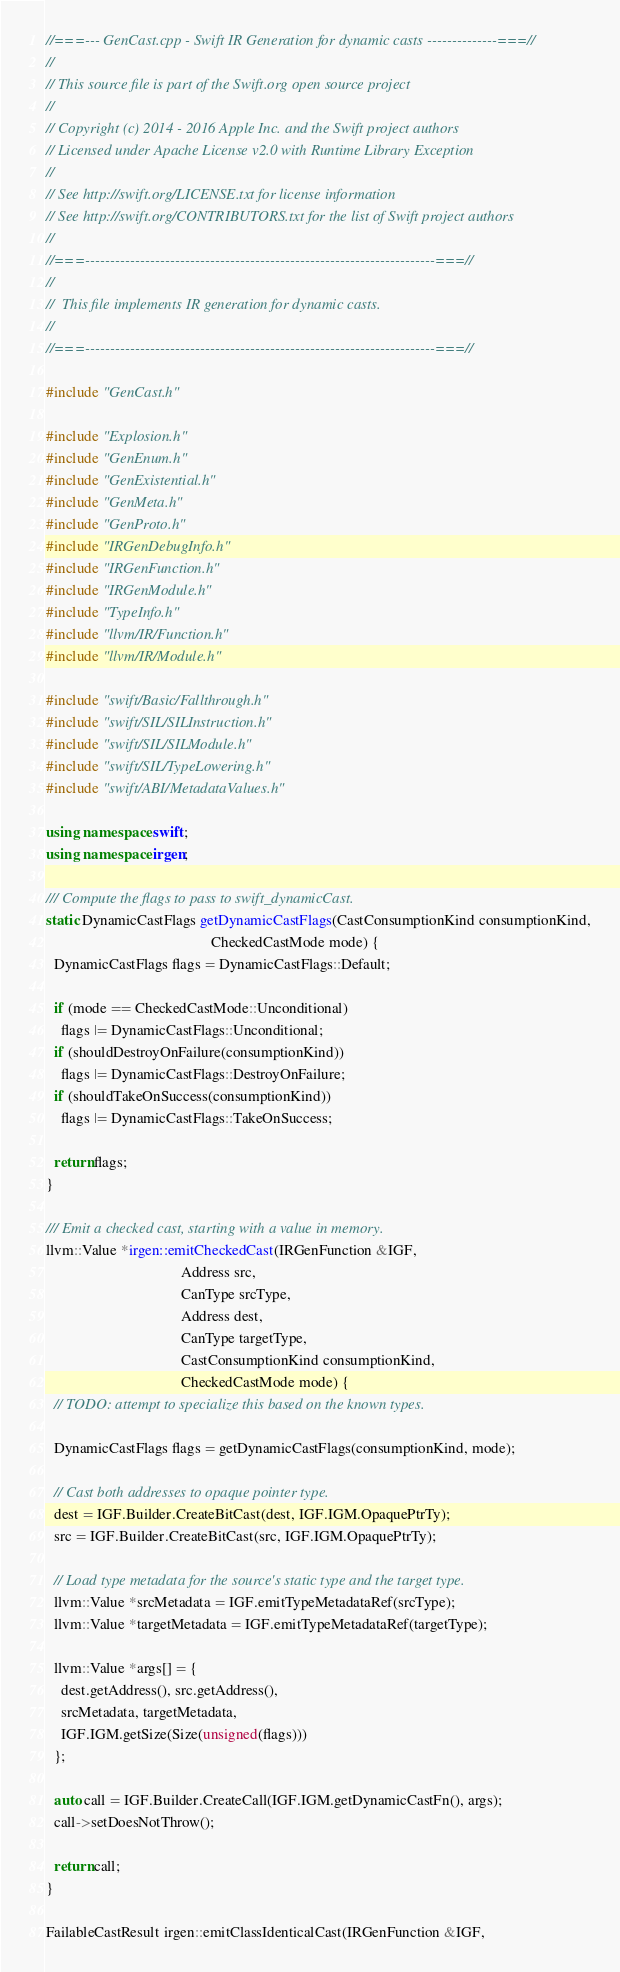Convert code to text. <code><loc_0><loc_0><loc_500><loc_500><_C++_>//===--- GenCast.cpp - Swift IR Generation for dynamic casts --------------===//
//
// This source file is part of the Swift.org open source project
//
// Copyright (c) 2014 - 2016 Apple Inc. and the Swift project authors
// Licensed under Apache License v2.0 with Runtime Library Exception
//
// See http://swift.org/LICENSE.txt for license information
// See http://swift.org/CONTRIBUTORS.txt for the list of Swift project authors
//
//===----------------------------------------------------------------------===//
//
//  This file implements IR generation for dynamic casts.
//
//===----------------------------------------------------------------------===//

#include "GenCast.h"

#include "Explosion.h"
#include "GenEnum.h"
#include "GenExistential.h"
#include "GenMeta.h"
#include "GenProto.h"
#include "IRGenDebugInfo.h"
#include "IRGenFunction.h"
#include "IRGenModule.h"
#include "TypeInfo.h"
#include "llvm/IR/Function.h"
#include "llvm/IR/Module.h"

#include "swift/Basic/Fallthrough.h"
#include "swift/SIL/SILInstruction.h"
#include "swift/SIL/SILModule.h"
#include "swift/SIL/TypeLowering.h"
#include "swift/ABI/MetadataValues.h"

using namespace swift;
using namespace irgen;

/// Compute the flags to pass to swift_dynamicCast.
static DynamicCastFlags getDynamicCastFlags(CastConsumptionKind consumptionKind,
                                            CheckedCastMode mode) {
  DynamicCastFlags flags = DynamicCastFlags::Default;

  if (mode == CheckedCastMode::Unconditional)
    flags |= DynamicCastFlags::Unconditional;
  if (shouldDestroyOnFailure(consumptionKind))
    flags |= DynamicCastFlags::DestroyOnFailure;
  if (shouldTakeOnSuccess(consumptionKind))
    flags |= DynamicCastFlags::TakeOnSuccess;

  return flags;
}

/// Emit a checked cast, starting with a value in memory.
llvm::Value *irgen::emitCheckedCast(IRGenFunction &IGF,
                                    Address src,
                                    CanType srcType,
                                    Address dest,
                                    CanType targetType,
                                    CastConsumptionKind consumptionKind,
                                    CheckedCastMode mode) {
  // TODO: attempt to specialize this based on the known types.

  DynamicCastFlags flags = getDynamicCastFlags(consumptionKind, mode);

  // Cast both addresses to opaque pointer type.
  dest = IGF.Builder.CreateBitCast(dest, IGF.IGM.OpaquePtrTy);
  src = IGF.Builder.CreateBitCast(src, IGF.IGM.OpaquePtrTy);

  // Load type metadata for the source's static type and the target type.
  llvm::Value *srcMetadata = IGF.emitTypeMetadataRef(srcType);
  llvm::Value *targetMetadata = IGF.emitTypeMetadataRef(targetType);

  llvm::Value *args[] = {
    dest.getAddress(), src.getAddress(),
    srcMetadata, targetMetadata,
    IGF.IGM.getSize(Size(unsigned(flags)))
  };

  auto call = IGF.Builder.CreateCall(IGF.IGM.getDynamicCastFn(), args);
  call->setDoesNotThrow();

  return call;
}

FailableCastResult irgen::emitClassIdenticalCast(IRGenFunction &IGF,</code> 